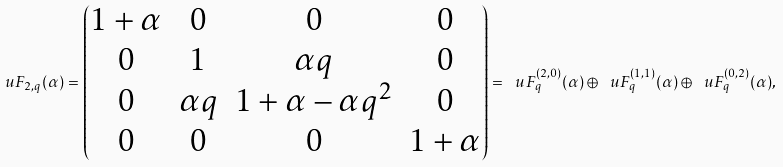<formula> <loc_0><loc_0><loc_500><loc_500>\ u F _ { 2 , q } ( \alpha ) = \begin{pmatrix} 1 + \alpha & 0 & 0 & 0 \\ 0 & 1 & \alpha q & 0 \\ 0 & \alpha q & 1 + \alpha - \alpha q ^ { 2 } & 0 \\ 0 & 0 & 0 & 1 + \alpha \end{pmatrix} = \ u F _ { q } ^ { ( 2 , 0 ) } ( \alpha ) \oplus \ u F _ { q } ^ { ( 1 , 1 ) } ( \alpha ) \oplus \ u F _ { q } ^ { ( 0 , 2 ) } ( \alpha ) ,</formula> 